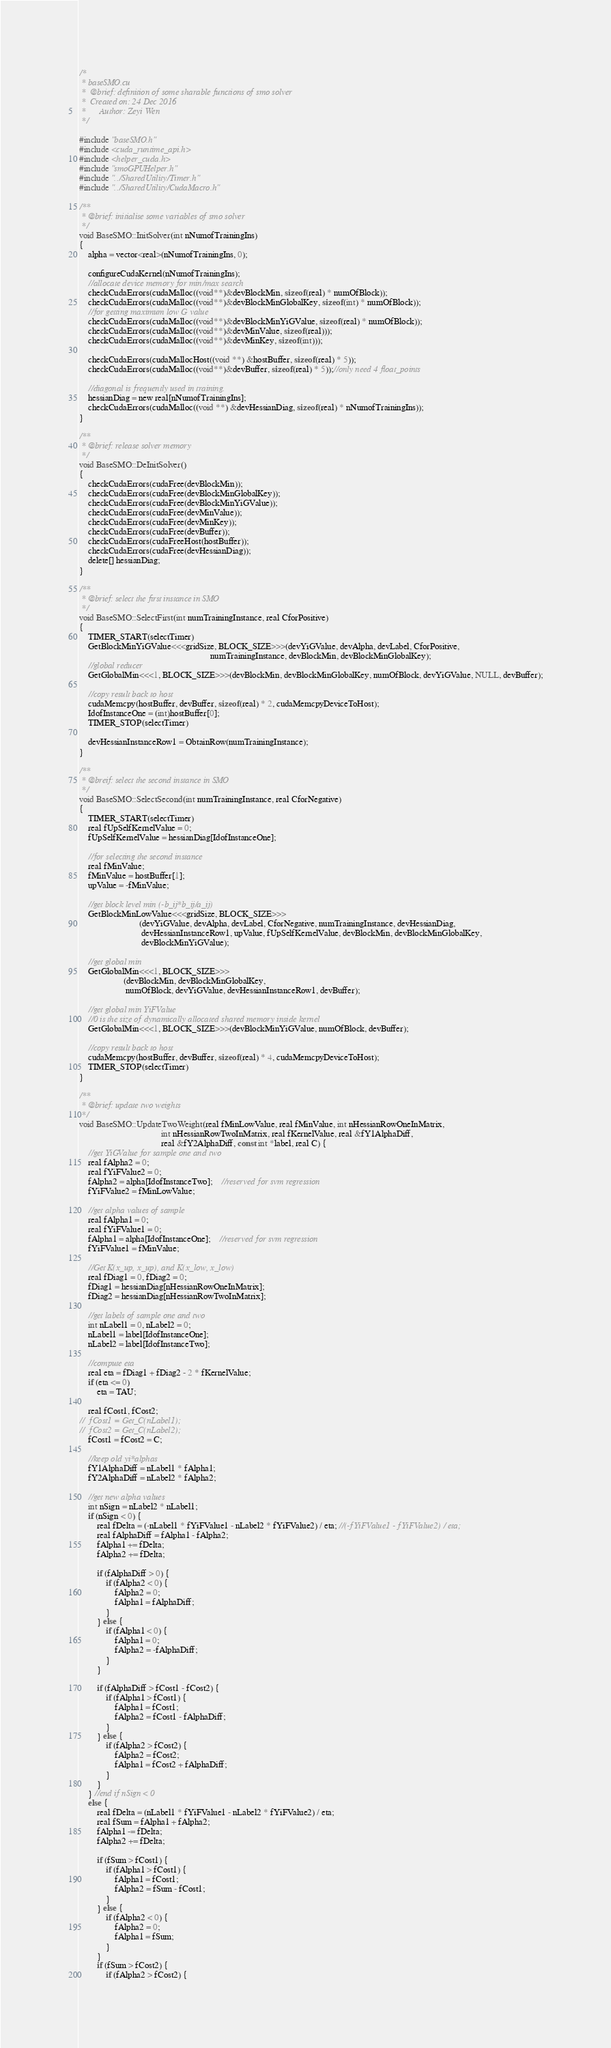Convert code to text. <code><loc_0><loc_0><loc_500><loc_500><_Cuda_>/*
 * baseSMO.cu
 *  @brief: definition of some sharable functions of smo solver
 *  Created on: 24 Dec 2016
 *      Author: Zeyi Wen
 */

#include "baseSMO.h"
#include <cuda_runtime_api.h>
#include <helper_cuda.h>
#include "smoGPUHelper.h"
#include "../SharedUtility/Timer.h"
#include "../SharedUtility/CudaMacro.h"

/**
 * @brief: initialise some variables of smo solver
 */
void BaseSMO::InitSolver(int nNumofTrainingIns)
{
	alpha = vector<real>(nNumofTrainingIns, 0);

    configureCudaKernel(nNumofTrainingIns);
	//allocate device memory for min/max search
	checkCudaErrors(cudaMalloc((void**)&devBlockMin, sizeof(real) * numOfBlock));
	checkCudaErrors(cudaMalloc((void**)&devBlockMinGlobalKey, sizeof(int) * numOfBlock));
	//for getting maximum low G value
	checkCudaErrors(cudaMalloc((void**)&devBlockMinYiGValue, sizeof(real) * numOfBlock));
	checkCudaErrors(cudaMalloc((void**)&devMinValue, sizeof(real)));
	checkCudaErrors(cudaMalloc((void**)&devMinKey, sizeof(int)));

	checkCudaErrors(cudaMallocHost((void **) &hostBuffer, sizeof(real) * 5));
	checkCudaErrors(cudaMalloc((void**)&devBuffer, sizeof(real) * 5));//only need 4 float_points

	//diagonal is frequently used in training.
	hessianDiag = new real[nNumofTrainingIns];
    checkCudaErrors(cudaMalloc((void **) &devHessianDiag, sizeof(real) * nNumofTrainingIns));
}

/**
 * @brief: release solver memory
 */
void BaseSMO::DeInitSolver()
{
    checkCudaErrors(cudaFree(devBlockMin));
    checkCudaErrors(cudaFree(devBlockMinGlobalKey));
    checkCudaErrors(cudaFree(devBlockMinYiGValue));
    checkCudaErrors(cudaFree(devMinValue));
    checkCudaErrors(cudaFree(devMinKey));
    checkCudaErrors(cudaFree(devBuffer));
    checkCudaErrors(cudaFreeHost(hostBuffer));
    checkCudaErrors(cudaFree(devHessianDiag));
    delete[] hessianDiag;
}

/**
 * @brief: select the first instance in SMO
 */
void BaseSMO::SelectFirst(int numTrainingInstance, real CforPositive)
{
    TIMER_START(selectTimer)
	GetBlockMinYiGValue<<<gridSize, BLOCK_SIZE>>>(devYiGValue, devAlpha, devLabel, CforPositive,
														   numTrainingInstance, devBlockMin, devBlockMinGlobalKey);
	//global reducer
	GetGlobalMin<<<1, BLOCK_SIZE>>>(devBlockMin, devBlockMinGlobalKey, numOfBlock, devYiGValue, NULL, devBuffer);

	//copy result back to host
	cudaMemcpy(hostBuffer, devBuffer, sizeof(real) * 2, cudaMemcpyDeviceToHost);
	IdofInstanceOne = (int)hostBuffer[0];
    TIMER_STOP(selectTimer)

	devHessianInstanceRow1 = ObtainRow(numTrainingInstance);
}

/**
 * @breif: select the second instance in SMO
 */
void BaseSMO::SelectSecond(int numTrainingInstance, real CforNegative)
{
    TIMER_START(selectTimer)
	real fUpSelfKernelValue = 0;
	fUpSelfKernelValue = hessianDiag[IdofInstanceOne];

	//for selecting the second instance
	real fMinValue;
	fMinValue = hostBuffer[1];
	upValue = -fMinValue;

	//get block level min (-b_ij*b_ij/a_ij)
	GetBlockMinLowValue<<<gridSize, BLOCK_SIZE>>>
						   (devYiGValue, devAlpha, devLabel, CforNegative, numTrainingInstance, devHessianDiag,
							devHessianInstanceRow1, upValue, fUpSelfKernelValue, devBlockMin, devBlockMinGlobalKey,
							devBlockMinYiGValue);

	//get global min
	GetGlobalMin<<<1, BLOCK_SIZE>>>
					(devBlockMin, devBlockMinGlobalKey,
					 numOfBlock, devYiGValue, devHessianInstanceRow1, devBuffer);

	//get global min YiFValue
	//0 is the size of dynamically allocated shared memory inside kernel
	GetGlobalMin<<<1, BLOCK_SIZE>>>(devBlockMinYiGValue, numOfBlock, devBuffer);

	//copy result back to host
	cudaMemcpy(hostBuffer, devBuffer, sizeof(real) * 4, cudaMemcpyDeviceToHost);
    TIMER_STOP(selectTimer)
}

/**
 * @brief: update two weights
 */
void BaseSMO::UpdateTwoWeight(real fMinLowValue, real fMinValue, int nHessianRowOneInMatrix,
                                     int nHessianRowTwoInMatrix, real fKernelValue, real &fY1AlphaDiff,
                                     real &fY2AlphaDiff, const int *label, real C) {
    //get YiGValue for sample one and two
    real fAlpha2 = 0;
    real fYiFValue2 = 0;
    fAlpha2 = alpha[IdofInstanceTwo];	//reserved for svm regression
    fYiFValue2 = fMinLowValue;

    //get alpha values of sample
    real fAlpha1 = 0;
    real fYiFValue1 = 0;
    fAlpha1 = alpha[IdofInstanceOne];	//reserved for svm regression
    fYiFValue1 = fMinValue;

    //Get K(x_up, x_up), and K(x_low, x_low)
    real fDiag1 = 0, fDiag2 = 0;
    fDiag1 = hessianDiag[nHessianRowOneInMatrix];
    fDiag2 = hessianDiag[nHessianRowTwoInMatrix];

    //get labels of sample one and two
    int nLabel1 = 0, nLabel2 = 0;
    nLabel1 = label[IdofInstanceOne];
    nLabel2 = label[IdofInstanceTwo];

    //compute eta
    real eta = fDiag1 + fDiag2 - 2 * fKernelValue;
    if (eta <= 0)
        eta = TAU;

    real fCost1, fCost2;
//	fCost1 = Get_C(nLabel1);
//	fCost2 = Get_C(nLabel2);
    fCost1 = fCost2 = C;

    //keep old yi*alphas
    fY1AlphaDiff = nLabel1 * fAlpha1;
    fY2AlphaDiff = nLabel2 * fAlpha2;

    //get new alpha values
    int nSign = nLabel2 * nLabel1;
    if (nSign < 0) {
        real fDelta = (-nLabel1 * fYiFValue1 - nLabel2 * fYiFValue2) / eta; //(-fYiFValue1 - fYiFValue2) / eta;
        real fAlphaDiff = fAlpha1 - fAlpha2;
        fAlpha1 += fDelta;
        fAlpha2 += fDelta;

        if (fAlphaDiff > 0) {
            if (fAlpha2 < 0) {
                fAlpha2 = 0;
                fAlpha1 = fAlphaDiff;
            }
        } else {
            if (fAlpha1 < 0) {
                fAlpha1 = 0;
                fAlpha2 = -fAlphaDiff;
            }
        }

        if (fAlphaDiff > fCost1 - fCost2) {
            if (fAlpha1 > fCost1) {
                fAlpha1 = fCost1;
                fAlpha2 = fCost1 - fAlphaDiff;
            }
        } else {
            if (fAlpha2 > fCost2) {
                fAlpha2 = fCost2;
                fAlpha1 = fCost2 + fAlphaDiff;
            }
        }
    } //end if nSign < 0
    else {
        real fDelta = (nLabel1 * fYiFValue1 - nLabel2 * fYiFValue2) / eta;
        real fSum = fAlpha1 + fAlpha2;
        fAlpha1 -= fDelta;
        fAlpha2 += fDelta;

        if (fSum > fCost1) {
            if (fAlpha1 > fCost1) {
                fAlpha1 = fCost1;
                fAlpha2 = fSum - fCost1;
            }
        } else {
            if (fAlpha2 < 0) {
                fAlpha2 = 0;
                fAlpha1 = fSum;
            }
        }
        if (fSum > fCost2) {
            if (fAlpha2 > fCost2) {</code> 